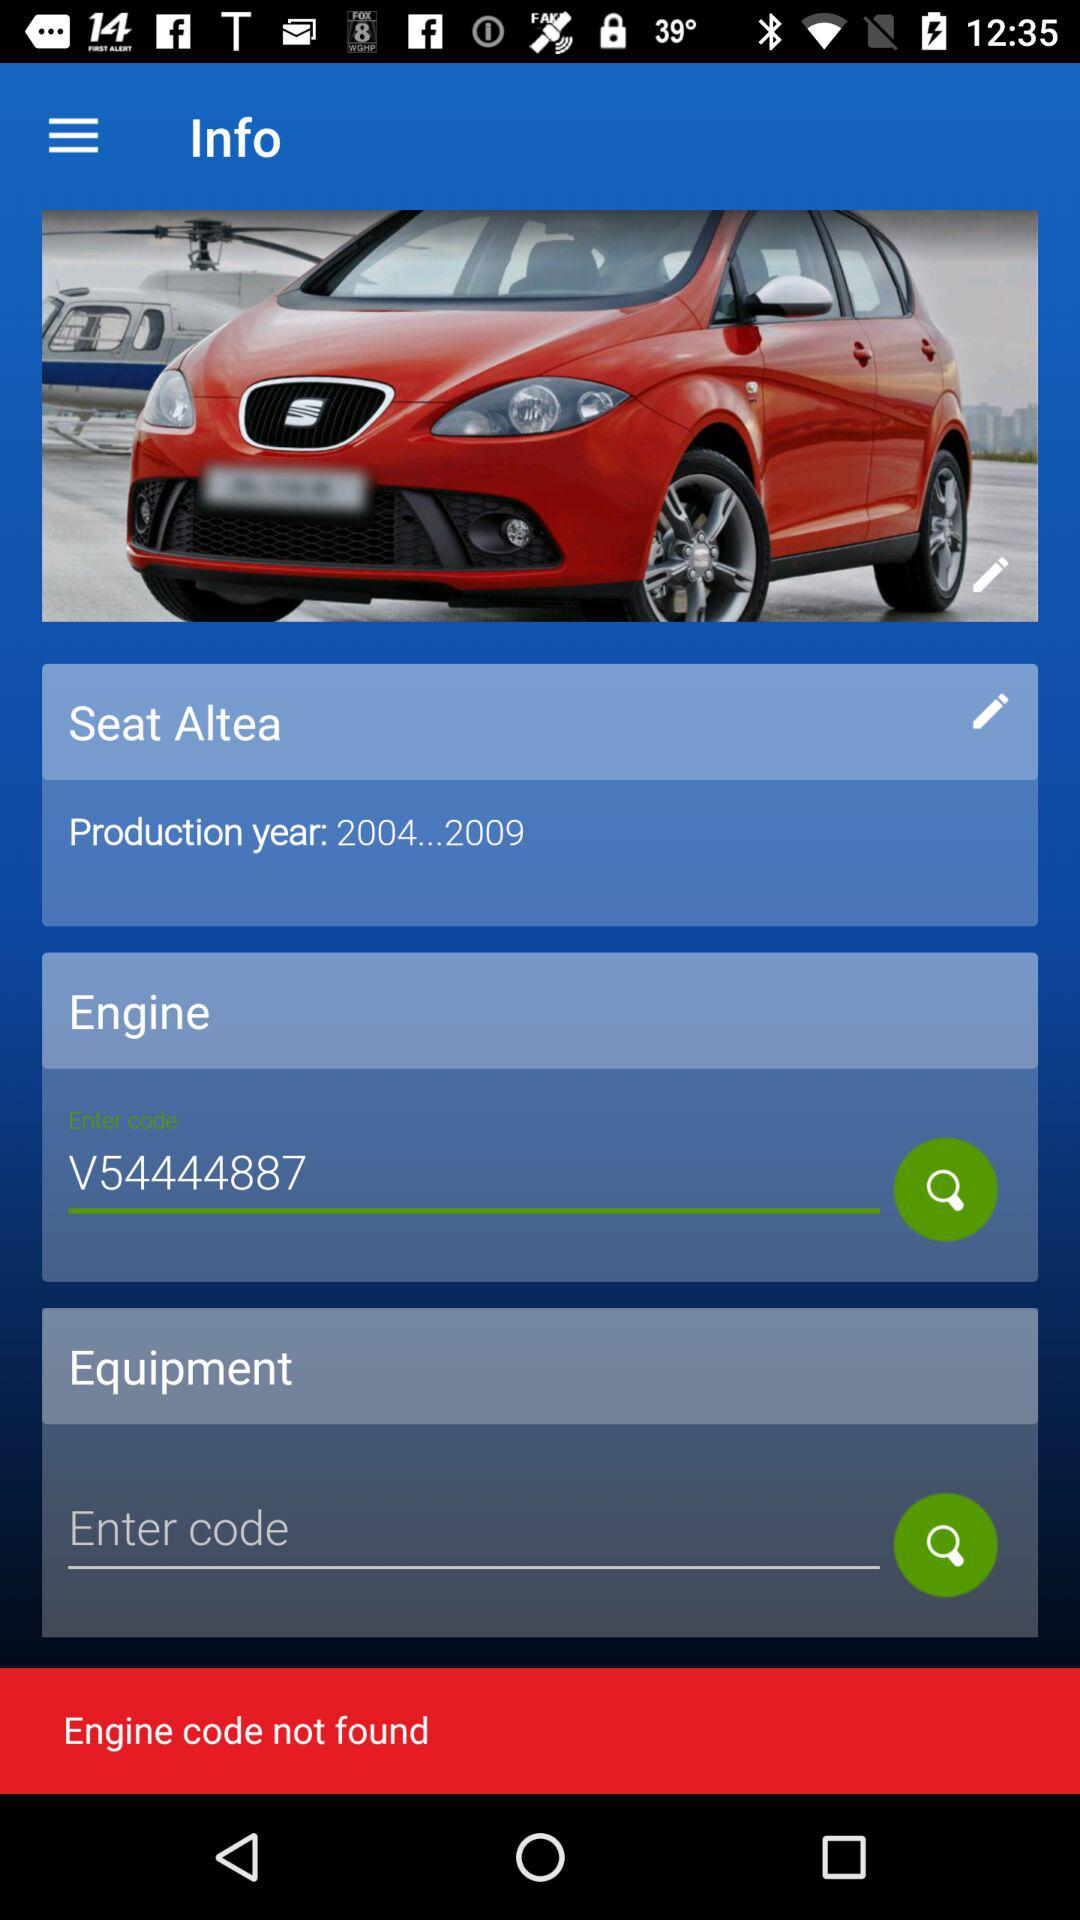What is the name of the car? The name of the car is Seat Altea. 